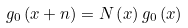<formula> <loc_0><loc_0><loc_500><loc_500>g _ { 0 } \left ( x + n \right ) = N \left ( x \right ) g _ { 0 } \left ( x \right )</formula> 